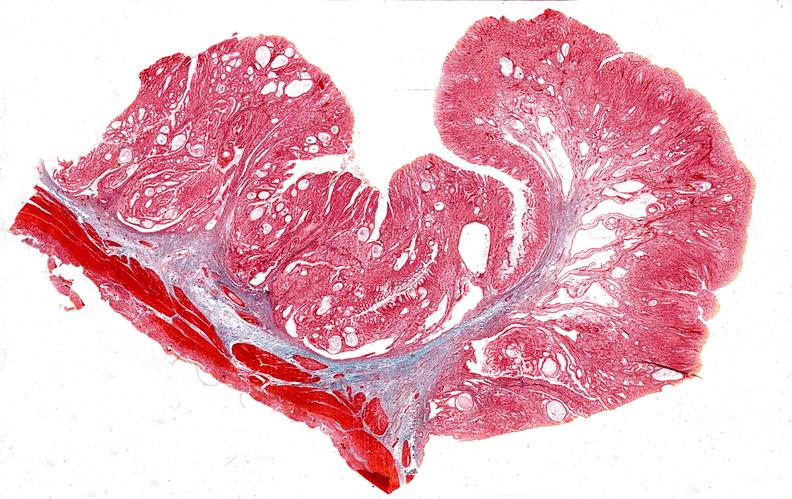what is present?
Answer the question using a single word or phrase. Gastrointestinal 